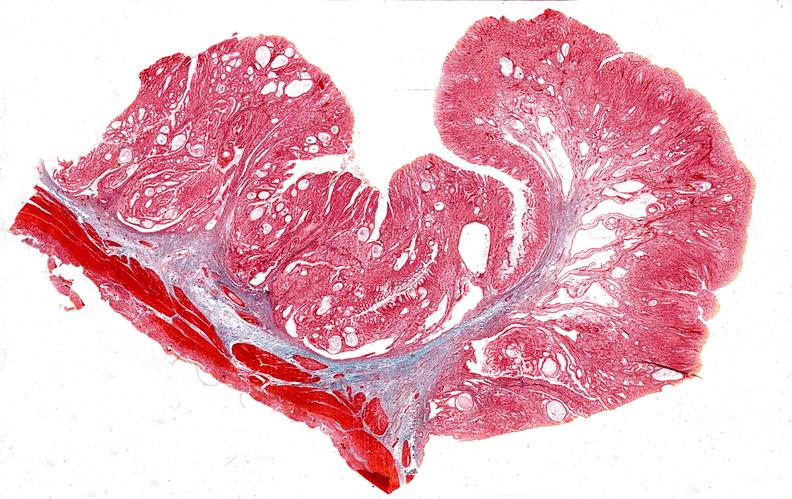what is present?
Answer the question using a single word or phrase. Gastrointestinal 